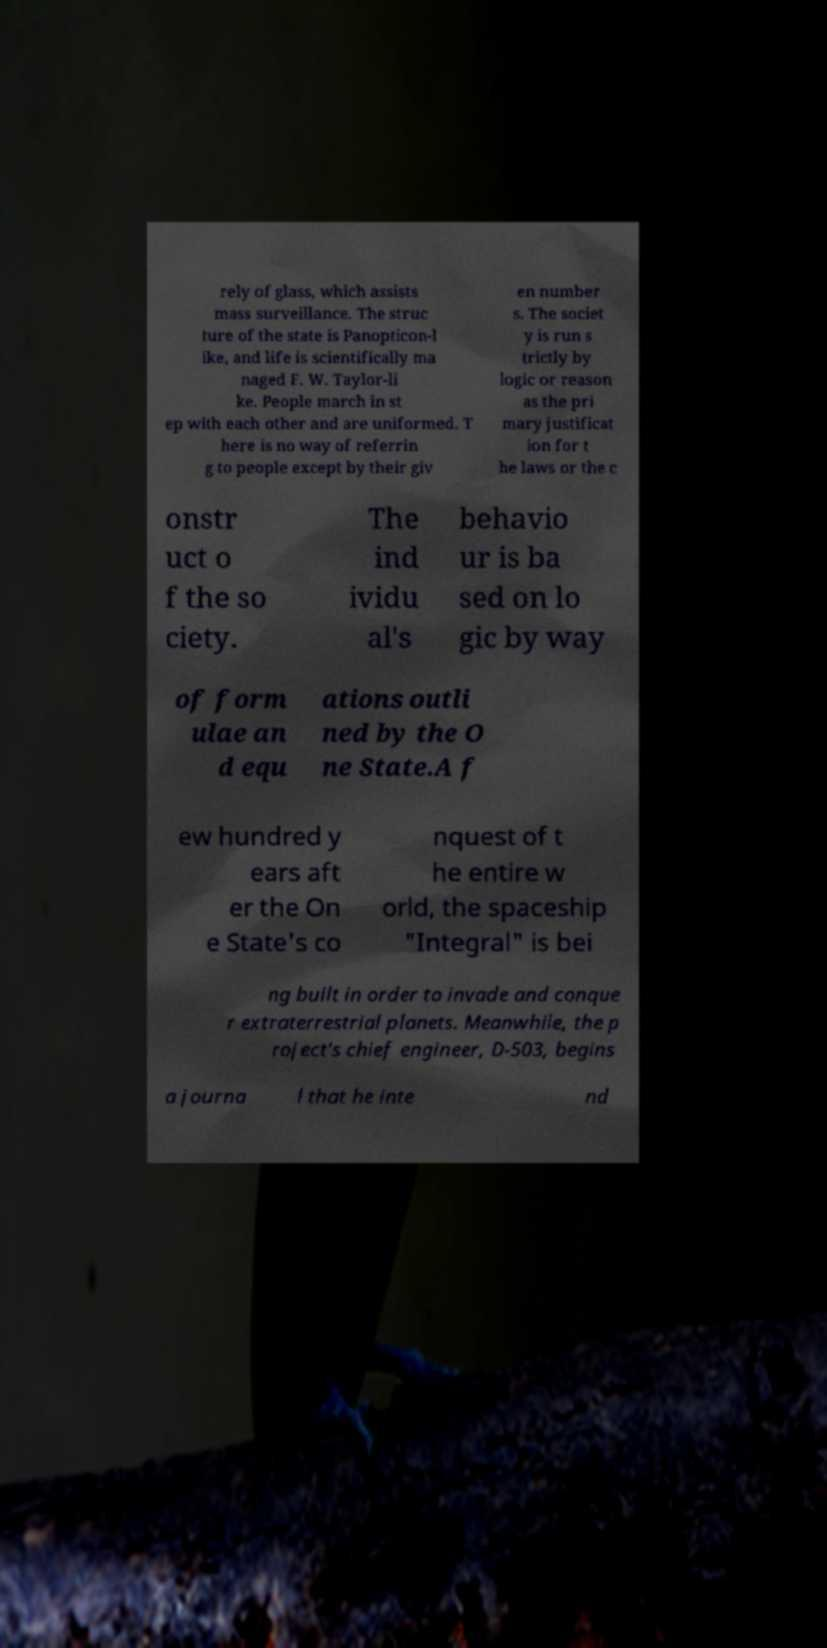Please read and relay the text visible in this image. What does it say? rely of glass, which assists mass surveillance. The struc ture of the state is Panopticon-l ike, and life is scientifically ma naged F. W. Taylor-li ke. People march in st ep with each other and are uniformed. T here is no way of referrin g to people except by their giv en number s. The societ y is run s trictly by logic or reason as the pri mary justificat ion for t he laws or the c onstr uct o f the so ciety. The ind ividu al's behavio ur is ba sed on lo gic by way of form ulae an d equ ations outli ned by the O ne State.A f ew hundred y ears aft er the On e State's co nquest of t he entire w orld, the spaceship "Integral" is bei ng built in order to invade and conque r extraterrestrial planets. Meanwhile, the p roject's chief engineer, D-503, begins a journa l that he inte nd 